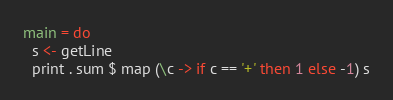Convert code to text. <code><loc_0><loc_0><loc_500><loc_500><_Haskell_>main = do
  s <- getLine
  print . sum $ map (\c -> if c == '+' then 1 else -1) s</code> 